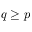Convert formula to latex. <formula><loc_0><loc_0><loc_500><loc_500>q \geq p</formula> 